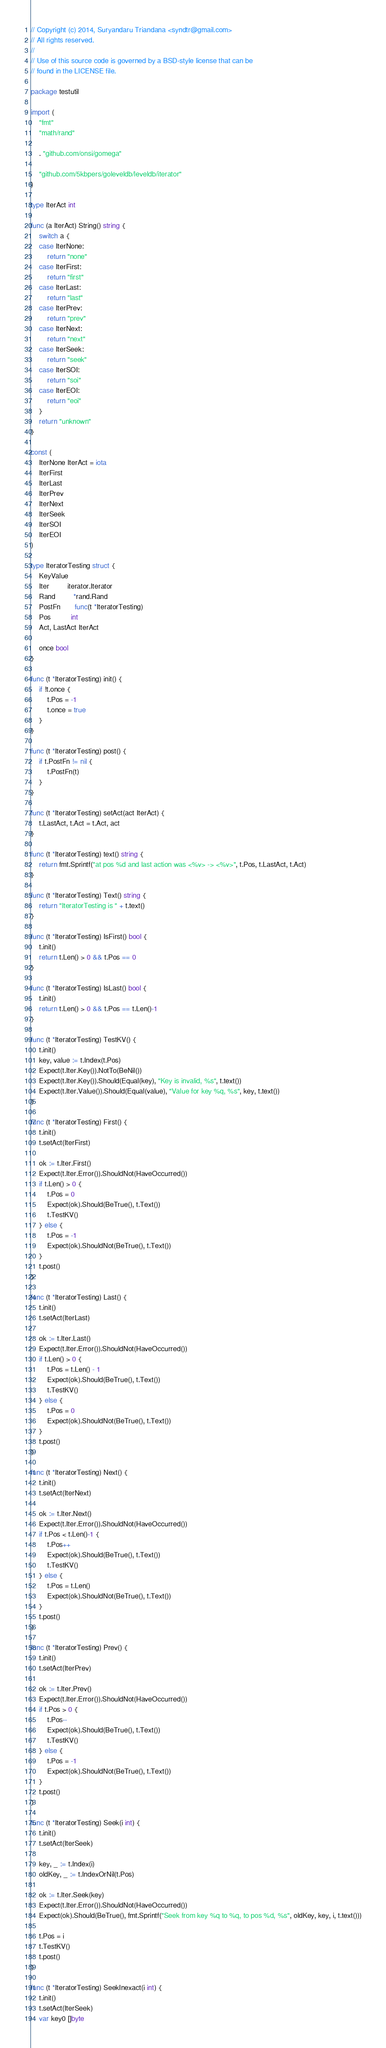Convert code to text. <code><loc_0><loc_0><loc_500><loc_500><_Go_>// Copyright (c) 2014, Suryandaru Triandana <syndtr@gmail.com>
// All rights reserved.
//
// Use of this source code is governed by a BSD-style license that can be
// found in the LICENSE file.

package testutil

import (
	"fmt"
	"math/rand"

	. "github.com/onsi/gomega"

	"github.com/5kbpers/goleveldb/leveldb/iterator"
)

type IterAct int

func (a IterAct) String() string {
	switch a {
	case IterNone:
		return "none"
	case IterFirst:
		return "first"
	case IterLast:
		return "last"
	case IterPrev:
		return "prev"
	case IterNext:
		return "next"
	case IterSeek:
		return "seek"
	case IterSOI:
		return "soi"
	case IterEOI:
		return "eoi"
	}
	return "unknown"
}

const (
	IterNone IterAct = iota
	IterFirst
	IterLast
	IterPrev
	IterNext
	IterSeek
	IterSOI
	IterEOI
)

type IteratorTesting struct {
	KeyValue
	Iter         iterator.Iterator
	Rand         *rand.Rand
	PostFn       func(t *IteratorTesting)
	Pos          int
	Act, LastAct IterAct

	once bool
}

func (t *IteratorTesting) init() {
	if !t.once {
		t.Pos = -1
		t.once = true
	}
}

func (t *IteratorTesting) post() {
	if t.PostFn != nil {
		t.PostFn(t)
	}
}

func (t *IteratorTesting) setAct(act IterAct) {
	t.LastAct, t.Act = t.Act, act
}

func (t *IteratorTesting) text() string {
	return fmt.Sprintf("at pos %d and last action was <%v> -> <%v>", t.Pos, t.LastAct, t.Act)
}

func (t *IteratorTesting) Text() string {
	return "IteratorTesting is " + t.text()
}

func (t *IteratorTesting) IsFirst() bool {
	t.init()
	return t.Len() > 0 && t.Pos == 0
}

func (t *IteratorTesting) IsLast() bool {
	t.init()
	return t.Len() > 0 && t.Pos == t.Len()-1
}

func (t *IteratorTesting) TestKV() {
	t.init()
	key, value := t.Index(t.Pos)
	Expect(t.Iter.Key()).NotTo(BeNil())
	Expect(t.Iter.Key()).Should(Equal(key), "Key is invalid, %s", t.text())
	Expect(t.Iter.Value()).Should(Equal(value), "Value for key %q, %s", key, t.text())
}

func (t *IteratorTesting) First() {
	t.init()
	t.setAct(IterFirst)

	ok := t.Iter.First()
	Expect(t.Iter.Error()).ShouldNot(HaveOccurred())
	if t.Len() > 0 {
		t.Pos = 0
		Expect(ok).Should(BeTrue(), t.Text())
		t.TestKV()
	} else {
		t.Pos = -1
		Expect(ok).ShouldNot(BeTrue(), t.Text())
	}
	t.post()
}

func (t *IteratorTesting) Last() {
	t.init()
	t.setAct(IterLast)

	ok := t.Iter.Last()
	Expect(t.Iter.Error()).ShouldNot(HaveOccurred())
	if t.Len() > 0 {
		t.Pos = t.Len() - 1
		Expect(ok).Should(BeTrue(), t.Text())
		t.TestKV()
	} else {
		t.Pos = 0
		Expect(ok).ShouldNot(BeTrue(), t.Text())
	}
	t.post()
}

func (t *IteratorTesting) Next() {
	t.init()
	t.setAct(IterNext)

	ok := t.Iter.Next()
	Expect(t.Iter.Error()).ShouldNot(HaveOccurred())
	if t.Pos < t.Len()-1 {
		t.Pos++
		Expect(ok).Should(BeTrue(), t.Text())
		t.TestKV()
	} else {
		t.Pos = t.Len()
		Expect(ok).ShouldNot(BeTrue(), t.Text())
	}
	t.post()
}

func (t *IteratorTesting) Prev() {
	t.init()
	t.setAct(IterPrev)

	ok := t.Iter.Prev()
	Expect(t.Iter.Error()).ShouldNot(HaveOccurred())
	if t.Pos > 0 {
		t.Pos--
		Expect(ok).Should(BeTrue(), t.Text())
		t.TestKV()
	} else {
		t.Pos = -1
		Expect(ok).ShouldNot(BeTrue(), t.Text())
	}
	t.post()
}

func (t *IteratorTesting) Seek(i int) {
	t.init()
	t.setAct(IterSeek)

	key, _ := t.Index(i)
	oldKey, _ := t.IndexOrNil(t.Pos)

	ok := t.Iter.Seek(key)
	Expect(t.Iter.Error()).ShouldNot(HaveOccurred())
	Expect(ok).Should(BeTrue(), fmt.Sprintf("Seek from key %q to %q, to pos %d, %s", oldKey, key, i, t.text()))

	t.Pos = i
	t.TestKV()
	t.post()
}

func (t *IteratorTesting) SeekInexact(i int) {
	t.init()
	t.setAct(IterSeek)
	var key0 []byte</code> 